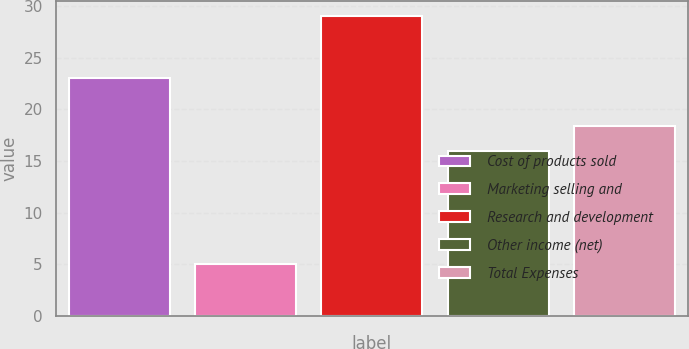<chart> <loc_0><loc_0><loc_500><loc_500><bar_chart><fcel>Cost of products sold<fcel>Marketing selling and<fcel>Research and development<fcel>Other income (net)<fcel>Total Expenses<nl><fcel>23<fcel>5<fcel>29<fcel>16<fcel>18.4<nl></chart> 